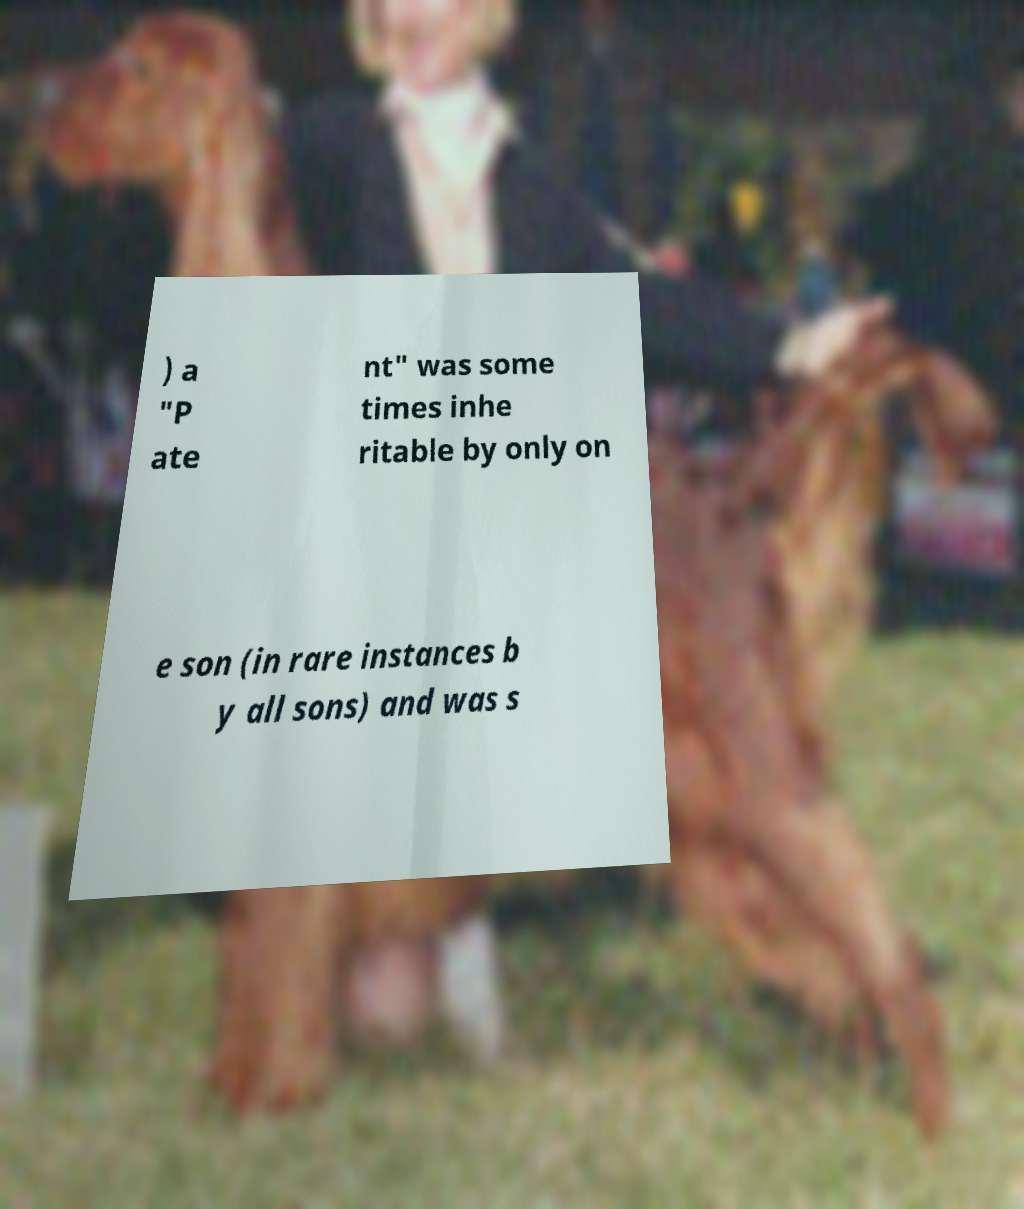Please identify and transcribe the text found in this image. ) a "P ate nt" was some times inhe ritable by only on e son (in rare instances b y all sons) and was s 